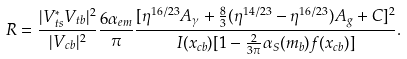<formula> <loc_0><loc_0><loc_500><loc_500>R = \frac { | V _ { t s } ^ { * } V _ { t b } | ^ { 2 } } { | V _ { c b } | ^ { 2 } } \frac { 6 \alpha _ { e m } } { \pi } \frac { [ \eta ^ { 1 6 / 2 3 } A _ { \gamma } + \frac { 8 } { 3 } ( \eta ^ { 1 4 / 2 3 } - \eta ^ { 1 6 / 2 3 } ) A _ { g } + C ] ^ { 2 } } { I ( x _ { c b } ) [ 1 - \frac { 2 } { 3 \pi } \alpha _ { S } ( m _ { b } ) f ( x _ { c b } ) ] } .</formula> 